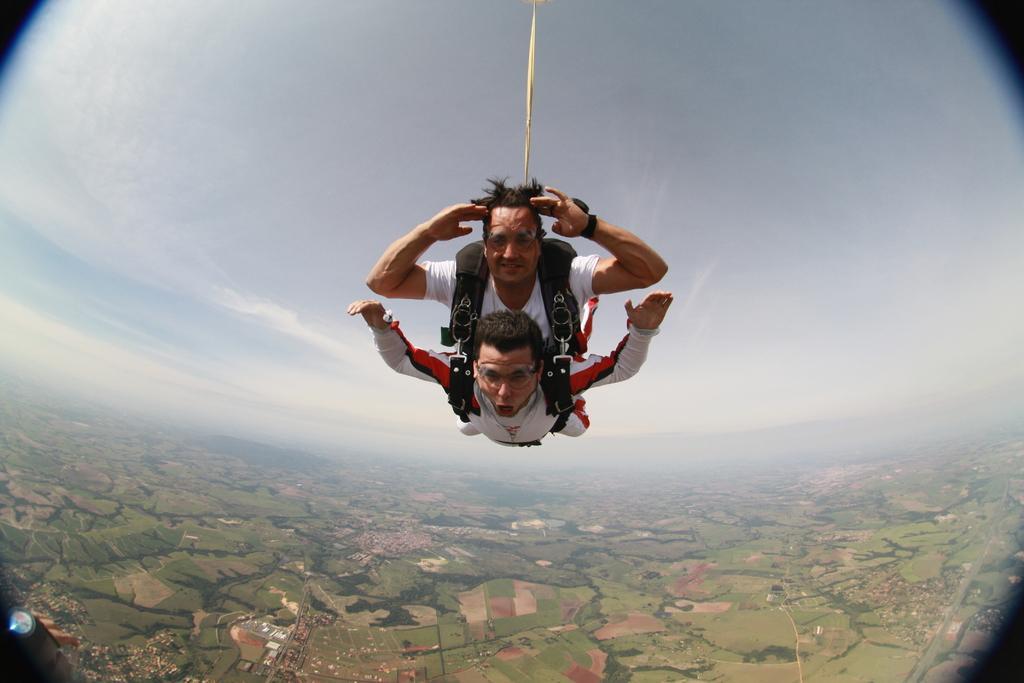Please provide a concise description of this image. At the bottom left side of the image, there is an object. In the center of the image, we can see two persons are skydiving. In the background, we can see the sky and land. 